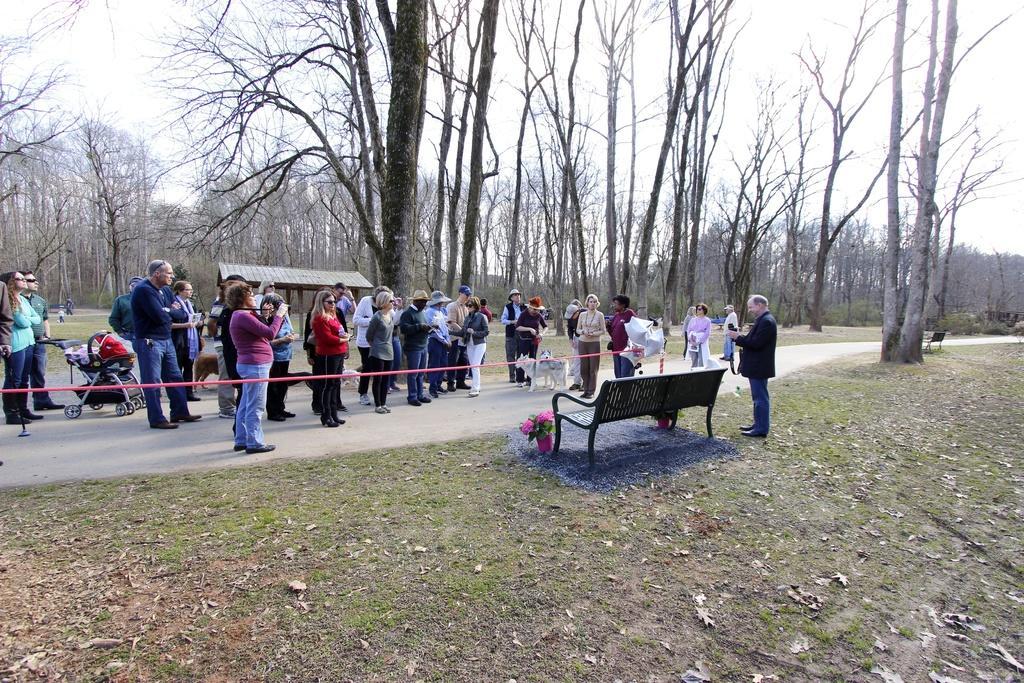In one or two sentences, can you explain what this image depicts? In this image we can see a group of people standing on the road. We can also see some animals, a rope and a person holding a trolley. On the bottom of the image we can see some benches, grass, dried leaves and some flower pots. On the backside we can see a group of trees and the sky which looks cloudy. 